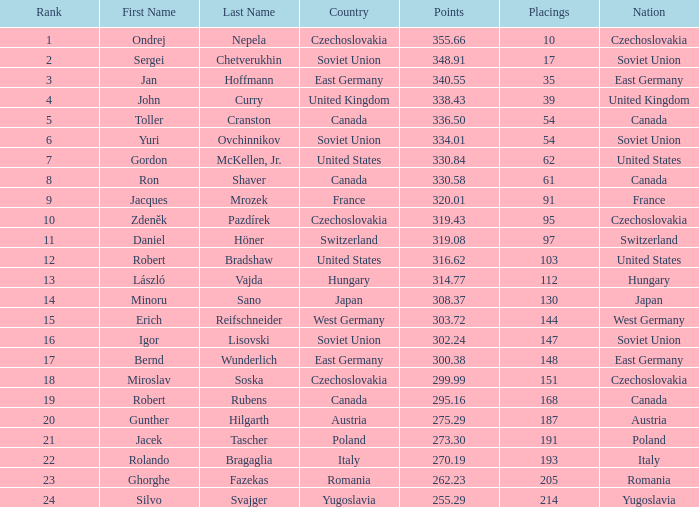Which Placings have a Nation of west germany, and Points larger than 303.72? None. 